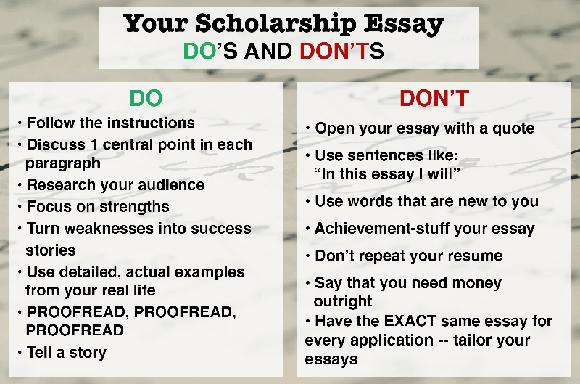How could a student integrate their understanding of their audience into a scholarship essay effectively? Integrating an understanding of your audience in a scholarship essay can be achieved by first researching the mission and values of the awarding organization. Then, align your essay to demonstrate how your personal goals and experiences resonate with those values. For instance, if applying for a scholarship from an organization that supports innovation in technology, a student could highlight how their project in creating a new app addresses a unique social need, reflecting both innovation and community service.  Could you give an example of how not to begin a scholarship essay? Certainly! You should avoid starting your scholarship essay with generic or overused lines such as 'Ever since I was a child, I’ve always been interested in science.' Instead, start with a unique aspect of your journey or a particular event that sparked your passion, making your introduction engaging and personal. 